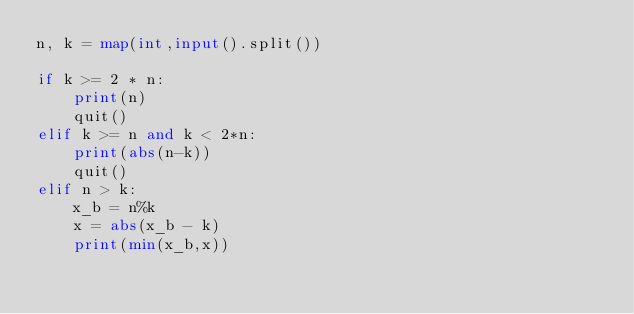<code> <loc_0><loc_0><loc_500><loc_500><_Python_>n, k = map(int,input().split())

if k >= 2 * n:
    print(n)
    quit()
elif k >= n and k < 2*n:
    print(abs(n-k))
    quit()
elif n > k:
    x_b = n%k
    x = abs(x_b - k)
    print(min(x_b,x))
</code> 